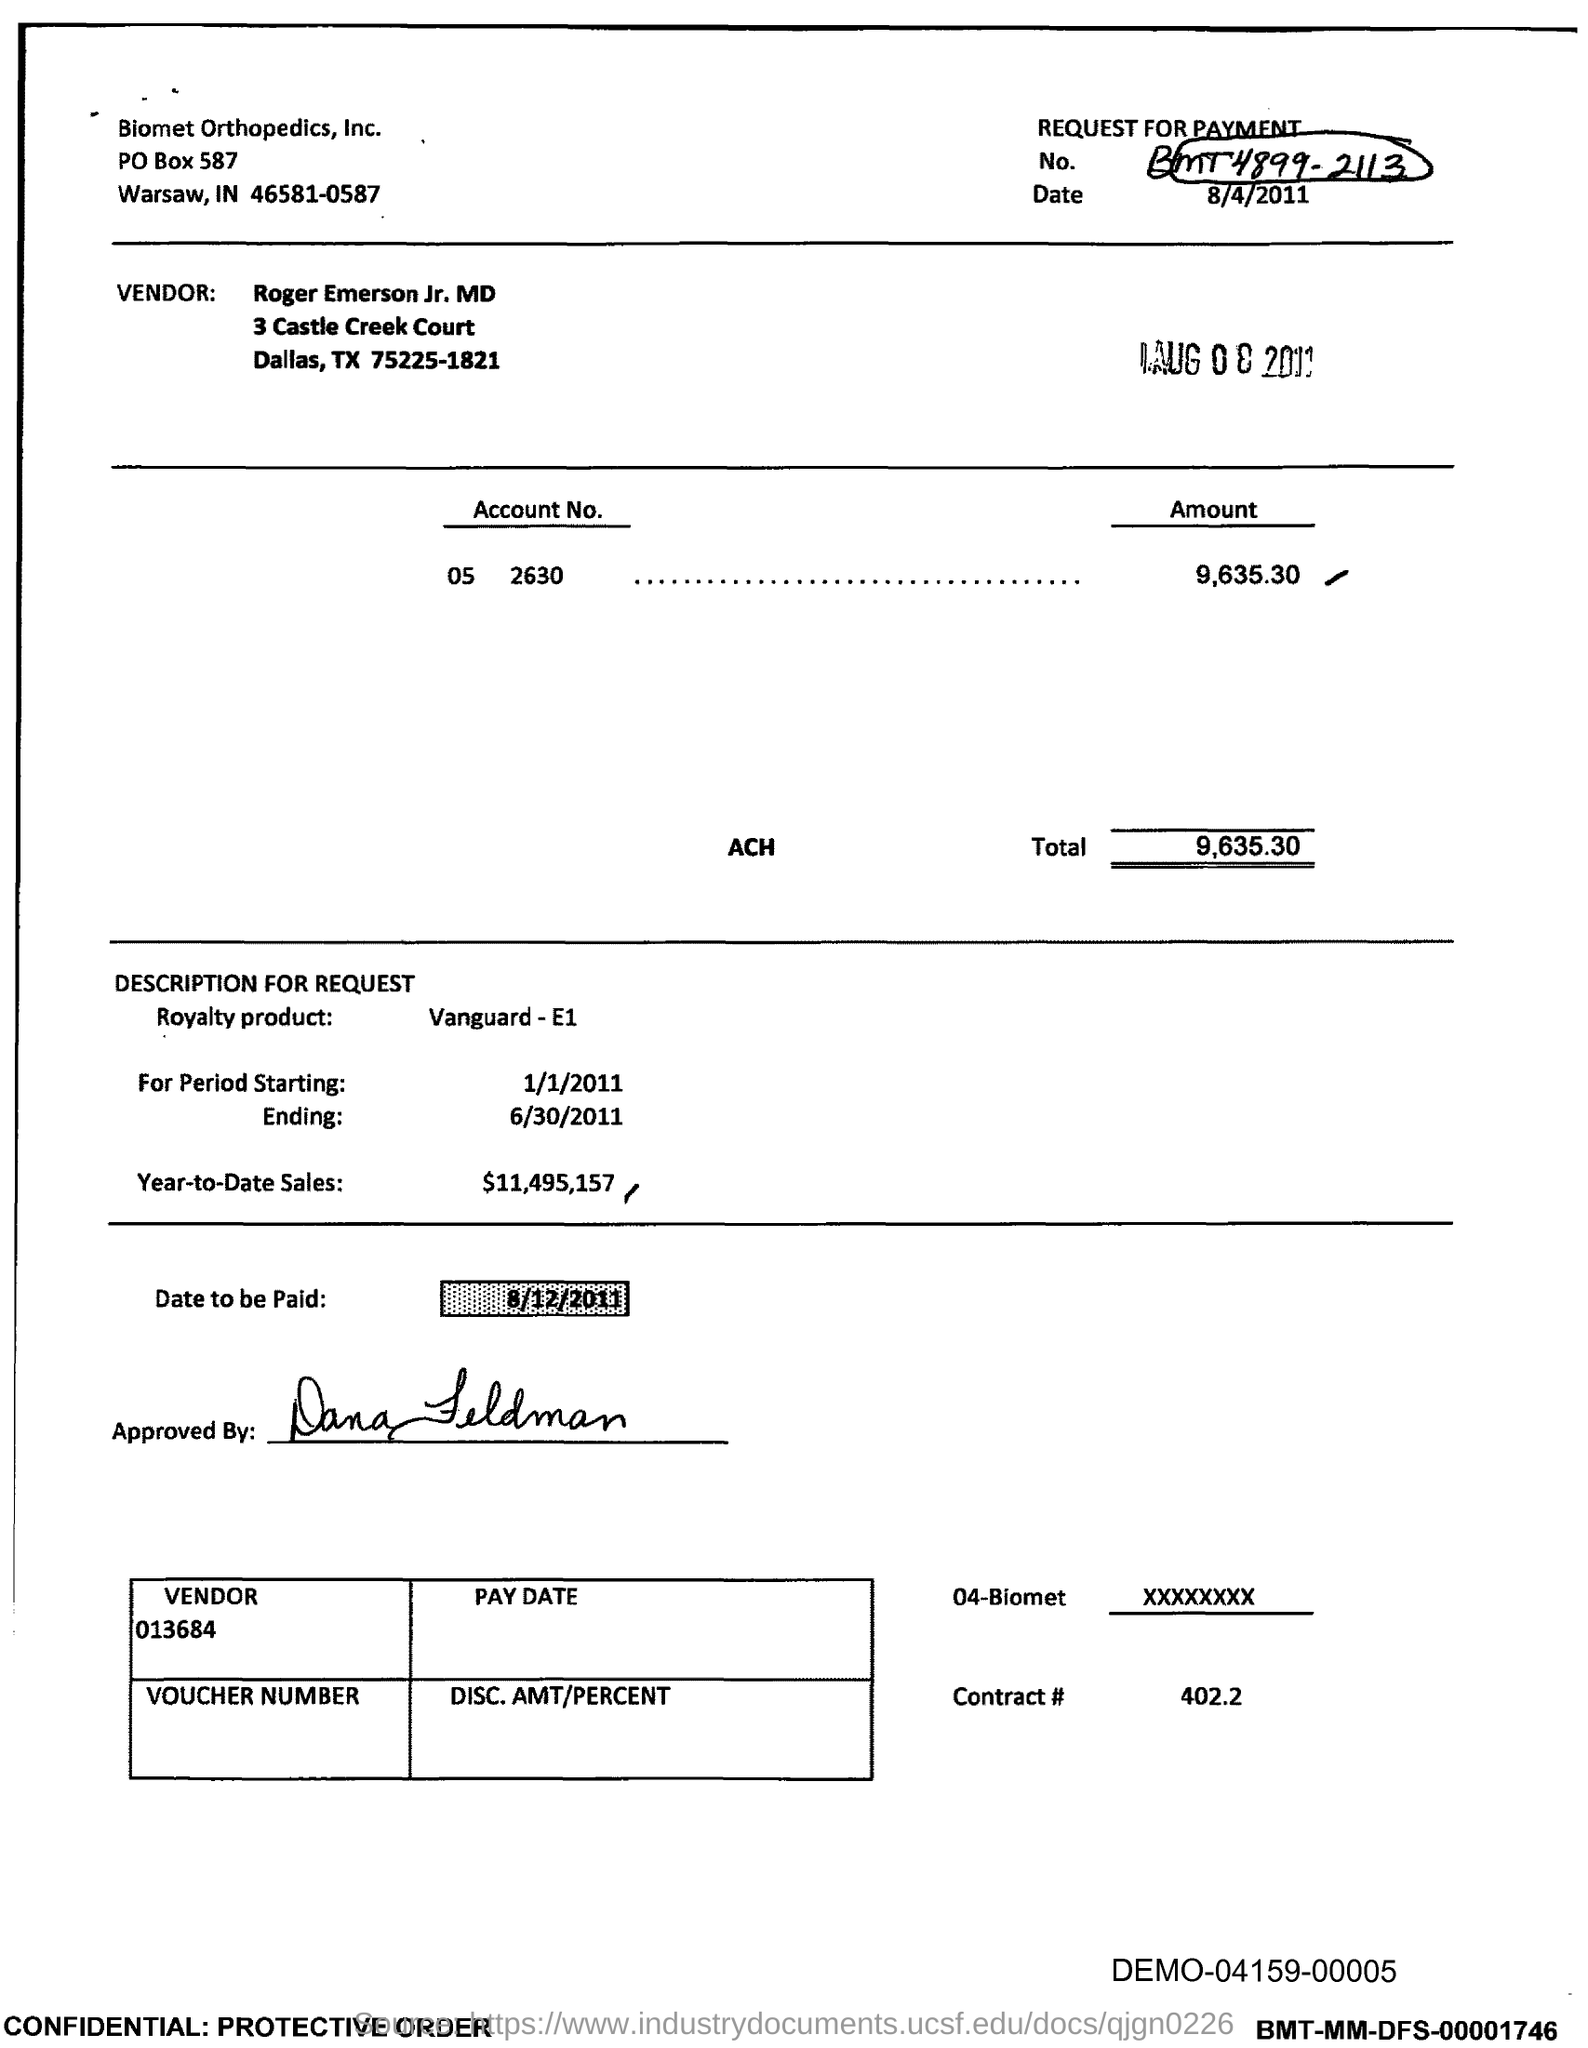List a handful of essential elements in this visual. The total amount to be paid, as specified in the document, is 9,635.30. The royalty period starting date mentioned in the document is January 1, 2011. The year-to-date sales of the royalty product are $11,495,157. The document contains a request for payment with the number BMT4899-2113. In the document, the royalty product is mentioned. 